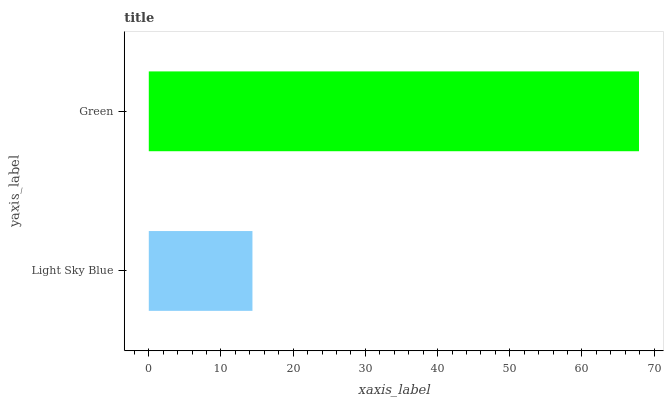Is Light Sky Blue the minimum?
Answer yes or no. Yes. Is Green the maximum?
Answer yes or no. Yes. Is Green the minimum?
Answer yes or no. No. Is Green greater than Light Sky Blue?
Answer yes or no. Yes. Is Light Sky Blue less than Green?
Answer yes or no. Yes. Is Light Sky Blue greater than Green?
Answer yes or no. No. Is Green less than Light Sky Blue?
Answer yes or no. No. Is Green the high median?
Answer yes or no. Yes. Is Light Sky Blue the low median?
Answer yes or no. Yes. Is Light Sky Blue the high median?
Answer yes or no. No. Is Green the low median?
Answer yes or no. No. 